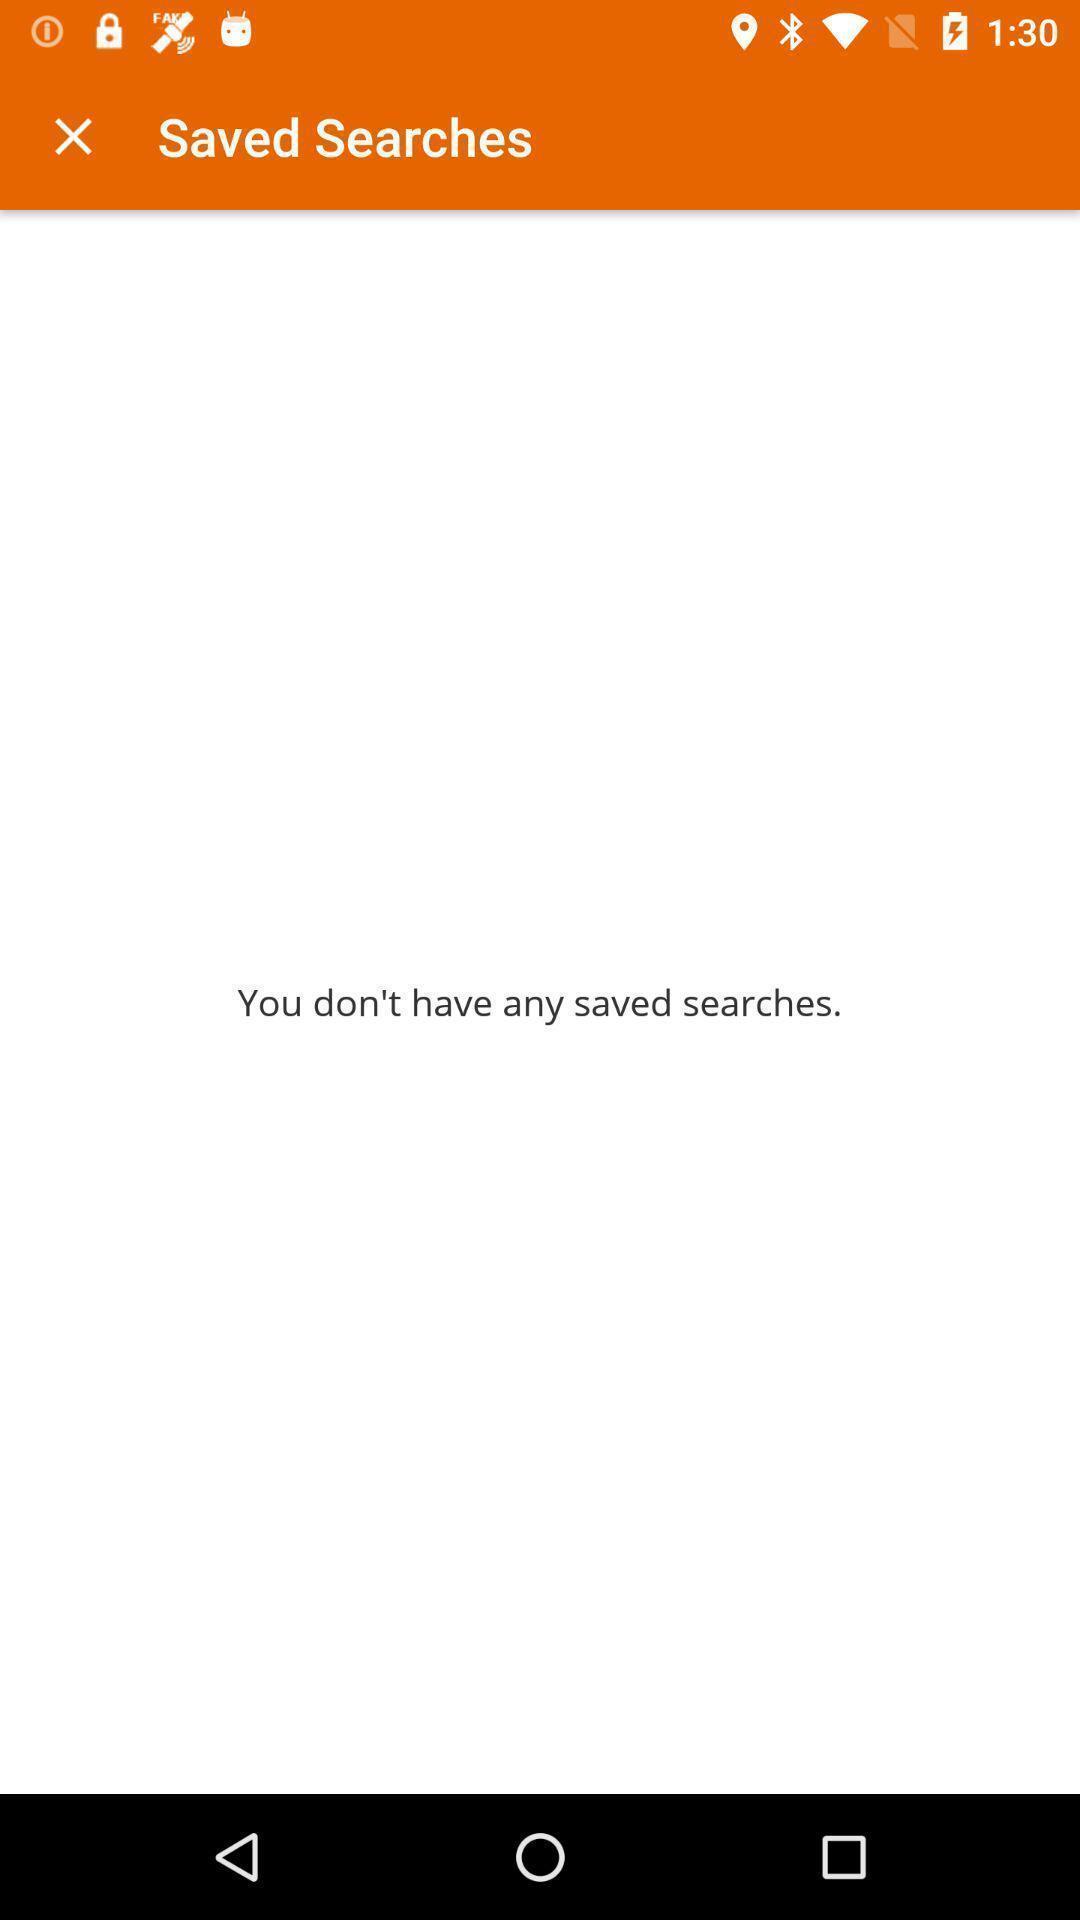Summarize the main components in this picture. Page shows saved searches. 